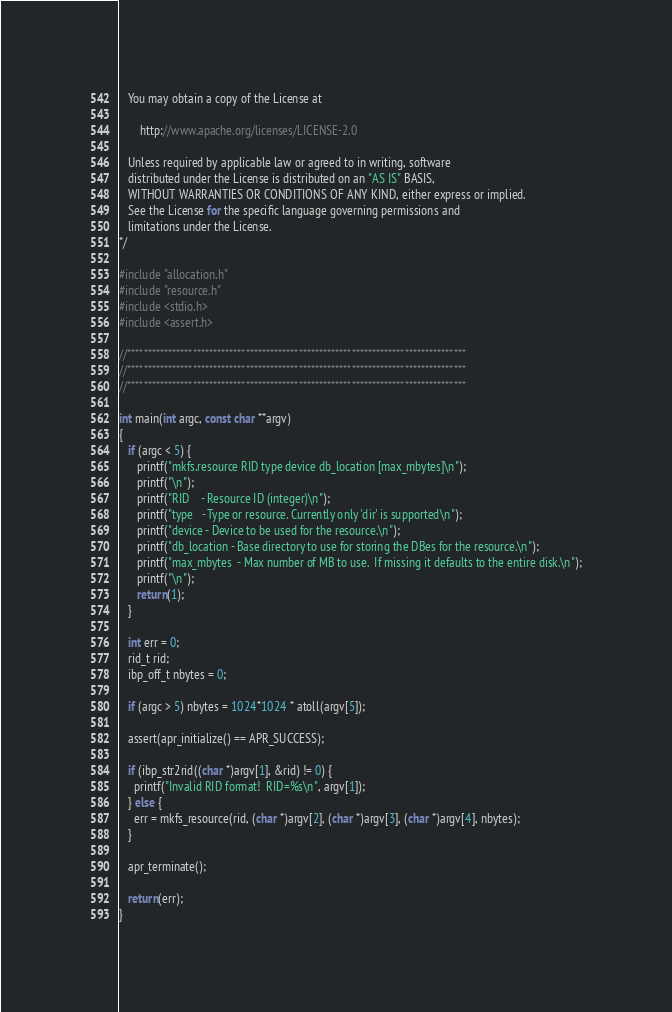Convert code to text. <code><loc_0><loc_0><loc_500><loc_500><_C_>   You may obtain a copy of the License at

       http://www.apache.org/licenses/LICENSE-2.0

   Unless required by applicable law or agreed to in writing, software
   distributed under the License is distributed on an "AS IS" BASIS,
   WITHOUT WARRANTIES OR CONDITIONS OF ANY KIND, either express or implied.
   See the License for the specific language governing permissions and
   limitations under the License.
*/

#include "allocation.h"
#include "resource.h"
#include <stdio.h>
#include <assert.h>

//***********************************************************************************
//***********************************************************************************
//***********************************************************************************

int main(int argc, const char **argv)
{
   if (argc < 5) {
      printf("mkfs.resource RID type device db_location [max_mbytes]\n");
      printf("\n");
      printf("RID    - Resource ID (integer)\n");
      printf("type   - Type or resource. Currently only 'dir' is supported\n");
      printf("device - Device to be used for the resource.\n");
      printf("db_location - Base directory to use for storing the DBes for the resource.\n");
      printf("max_mbytes  - Max number of MB to use.  If missing it defaults to the entire disk.\n");
      printf("\n");      
      return(1);
   }

   int err = 0;
   rid_t rid;
   ibp_off_t nbytes = 0;

   if (argc > 5) nbytes = 1024*1024 * atoll(argv[5]);

   assert(apr_initialize() == APR_SUCCESS);

   if (ibp_str2rid((char *)argv[1], &rid) != 0) {
     printf("Invalid RID format!  RID=%s\n", argv[1]);
   } else {
     err = mkfs_resource(rid, (char *)argv[2], (char *)argv[3], (char *)argv[4], nbytes);
   }

   apr_terminate();

   return(err);
}

</code> 